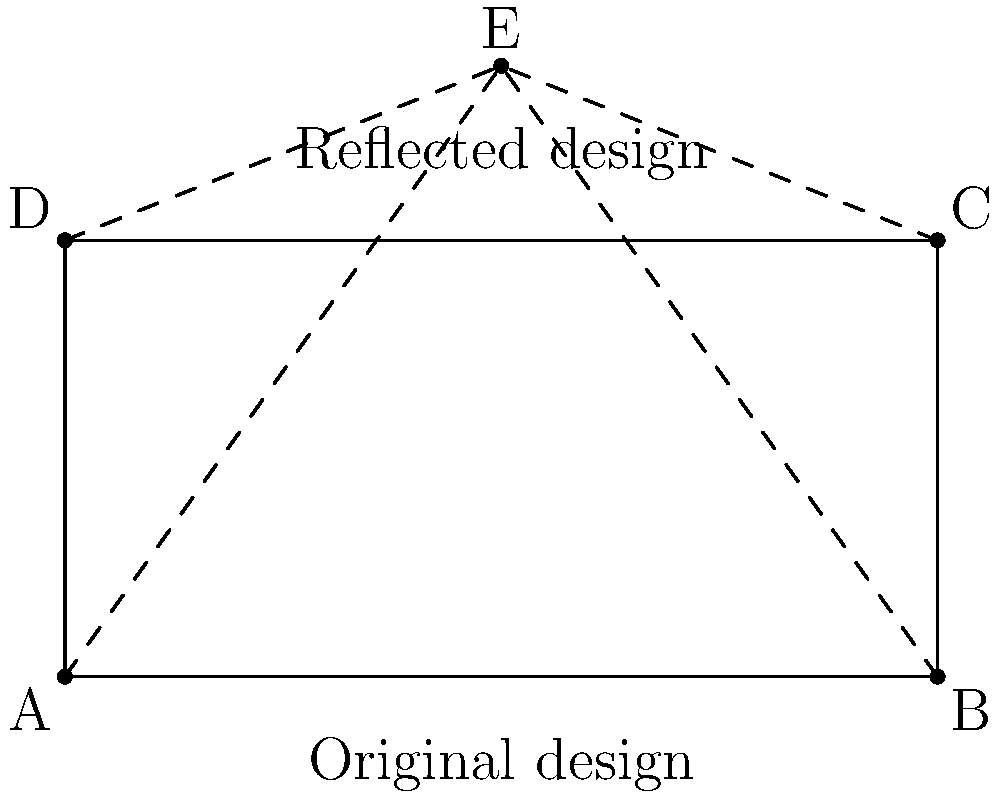For a rooftop wedding, you're planning to create a mirrored string light design. The original design forms a triangle with vertices at points A(0,0), B(10,0), and E(5,7) on a coordinate plane. If you reflect this design over the line y=5 to create a symmetrical pattern, what will be the coordinates of the reflected point E'? To solve this problem, we'll follow these steps:

1) The line of reflection is y=5, which means we need to reflect point E over this line.

2) The formula for reflecting a point (x,y) over a horizontal line y=k is:
   $$(x, 2k-y)$$

3) In our case:
   x = 5 (doesn't change in a horizontal reflection)
   y = 7 (original y-coordinate of point E)
   k = 5 (the y-value of our reflection line)

4) Applying the formula:
   $$E' = (5, 2(5)-7)$$
   $$E' = (5, 10-7)$$
   $$E' = (5, 3)$$

5) Therefore, the coordinates of the reflected point E' are (5,3).

This reflection creates a symmetrical design on both sides of the rooftop, with the original triangle ABC mirrored to create triangle DCE'.
Answer: (5,3) 